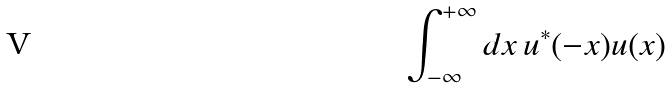Convert formula to latex. <formula><loc_0><loc_0><loc_500><loc_500>\int _ { - \infty } ^ { + \infty } d x \, u ^ { * } ( - x ) u ( x )</formula> 